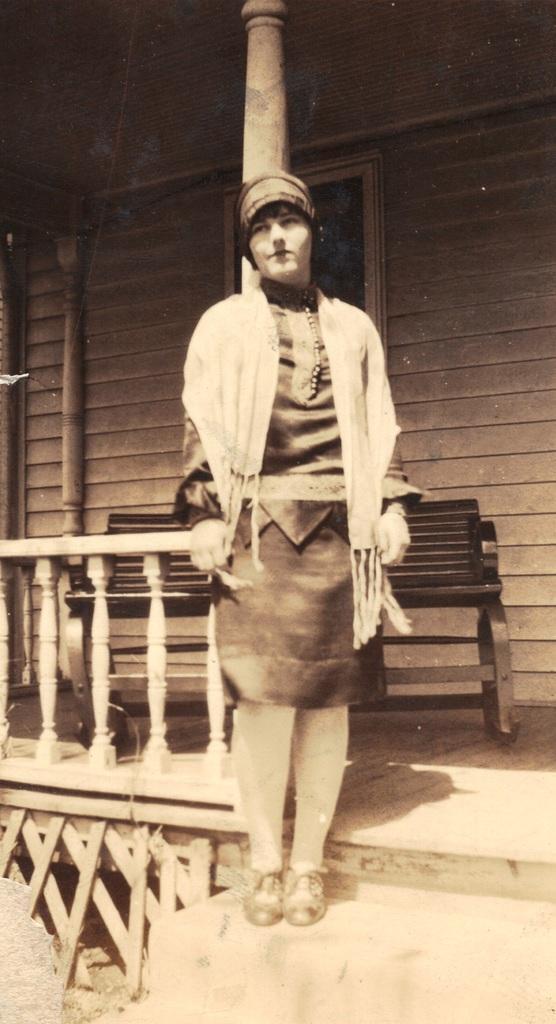Can you describe this image briefly? In the picture we can see a black and white photograph, in that we can see a person standing near to the home and we can see a pillar and a railing and the person is wearing a cap. 